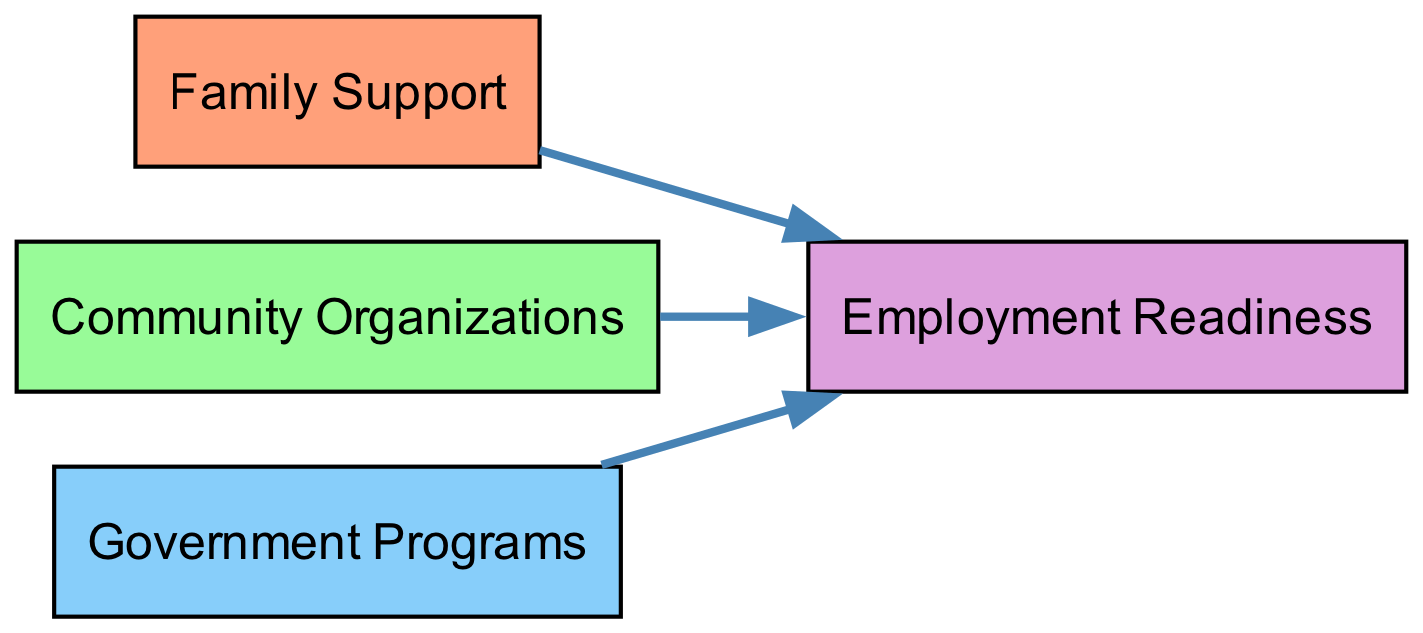What is the first node in the pathway? The first node in the pathway, as indicated in the diagram, is "Release from Incarceration." This node represents the starting point for individuals with criminal records seeking employment pathways.
Answer: Release from Incarceration How many edges are there connecting to "job_search"? By reviewing the edges leading to and from the "job_search" node, we see there are three connections: one from "education," one from "vocational_training," and one from "employment_gaps." Thus, there are three edges connecting to "job_search."
Answer: 3 What are the support systems available after gaining employment? The support systems available after gaining employment are represented as nodes connected to "employment." These include "Mentorship Programs," "Community Organizations," and "Rehabilitation Programs."
Answer: Mentorship Programs, Community Organizations, Rehabilitation Programs What node indicates skills that need improvement? The node that indicates skills needing improvement is "Gaps in Skills," which highlights the challenges related to one’s qualifications in the job market.
Answer: Gaps in Skills Which node connects to both "vocational_training" and "mentorship"? The node that connects to both "vocational_training" and "mentorship" is "Support Systems." It serves as a bridge between these two supportive elements along the pathway to employment readiness.
Answer: Support Systems How does "job_search" relate to "discrimination"? The "job_search" node has a directed edge that leads to "Workplace Discrimination." This indicates that during the job search process, individuals with criminal records may encounter discrimination as a barrier.
Answer: Workplace Discrimination What is one potential barrier highlighted in the diagram? One potential barrier highlighted in the diagram is "Workplace Discrimination," which refers to the negative bias that individuals with criminal records may face when applying for jobs.
Answer: Workplace Discrimination List all nodes that are sources of support systems. The nodes that are sources of support systems include "Mentorship Programs," "Community Organizations," and "Rehabilitation Programs." These resources assist individuals in becoming employment-ready.
Answer: Mentorship Programs, Community Organizations, Rehabilitation Programs What is the last step in the pathway leading to employment? The last step in the pathway leading to employment is the "Employment" node, which signifies successful placement in a job after navigating the previous stages.
Answer: Employment 